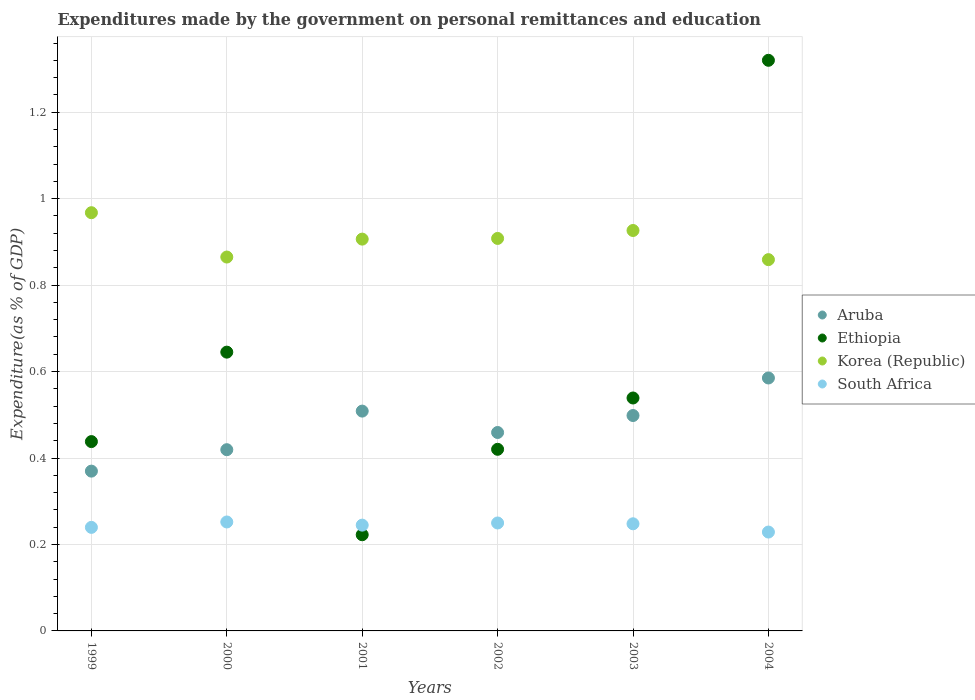Is the number of dotlines equal to the number of legend labels?
Your answer should be very brief. Yes. What is the expenditures made by the government on personal remittances and education in Aruba in 2002?
Your response must be concise. 0.46. Across all years, what is the maximum expenditures made by the government on personal remittances and education in Aruba?
Provide a short and direct response. 0.59. Across all years, what is the minimum expenditures made by the government on personal remittances and education in Korea (Republic)?
Offer a very short reply. 0.86. What is the total expenditures made by the government on personal remittances and education in Ethiopia in the graph?
Offer a very short reply. 3.58. What is the difference between the expenditures made by the government on personal remittances and education in South Africa in 2000 and that in 2004?
Provide a short and direct response. 0.02. What is the difference between the expenditures made by the government on personal remittances and education in Ethiopia in 2004 and the expenditures made by the government on personal remittances and education in Korea (Republic) in 1999?
Make the answer very short. 0.35. What is the average expenditures made by the government on personal remittances and education in South Africa per year?
Offer a very short reply. 0.24. In the year 2002, what is the difference between the expenditures made by the government on personal remittances and education in Korea (Republic) and expenditures made by the government on personal remittances and education in South Africa?
Your answer should be compact. 0.66. What is the ratio of the expenditures made by the government on personal remittances and education in South Africa in 2002 to that in 2003?
Ensure brevity in your answer.  1.01. What is the difference between the highest and the second highest expenditures made by the government on personal remittances and education in Ethiopia?
Offer a terse response. 0.68. What is the difference between the highest and the lowest expenditures made by the government on personal remittances and education in South Africa?
Keep it short and to the point. 0.02. Is it the case that in every year, the sum of the expenditures made by the government on personal remittances and education in Ethiopia and expenditures made by the government on personal remittances and education in Korea (Republic)  is greater than the sum of expenditures made by the government on personal remittances and education in Aruba and expenditures made by the government on personal remittances and education in South Africa?
Provide a succinct answer. Yes. Is it the case that in every year, the sum of the expenditures made by the government on personal remittances and education in South Africa and expenditures made by the government on personal remittances and education in Aruba  is greater than the expenditures made by the government on personal remittances and education in Ethiopia?
Your response must be concise. No. Are the values on the major ticks of Y-axis written in scientific E-notation?
Give a very brief answer. No. Where does the legend appear in the graph?
Your response must be concise. Center right. How many legend labels are there?
Your response must be concise. 4. What is the title of the graph?
Your response must be concise. Expenditures made by the government on personal remittances and education. What is the label or title of the X-axis?
Offer a terse response. Years. What is the label or title of the Y-axis?
Keep it short and to the point. Expenditure(as % of GDP). What is the Expenditure(as % of GDP) in Aruba in 1999?
Provide a succinct answer. 0.37. What is the Expenditure(as % of GDP) in Ethiopia in 1999?
Keep it short and to the point. 0.44. What is the Expenditure(as % of GDP) of Korea (Republic) in 1999?
Give a very brief answer. 0.97. What is the Expenditure(as % of GDP) of South Africa in 1999?
Your answer should be compact. 0.24. What is the Expenditure(as % of GDP) in Aruba in 2000?
Your answer should be very brief. 0.42. What is the Expenditure(as % of GDP) in Ethiopia in 2000?
Provide a short and direct response. 0.64. What is the Expenditure(as % of GDP) in Korea (Republic) in 2000?
Provide a short and direct response. 0.86. What is the Expenditure(as % of GDP) in South Africa in 2000?
Keep it short and to the point. 0.25. What is the Expenditure(as % of GDP) of Aruba in 2001?
Offer a terse response. 0.51. What is the Expenditure(as % of GDP) in Ethiopia in 2001?
Your answer should be very brief. 0.22. What is the Expenditure(as % of GDP) of Korea (Republic) in 2001?
Your answer should be very brief. 0.91. What is the Expenditure(as % of GDP) in South Africa in 2001?
Keep it short and to the point. 0.24. What is the Expenditure(as % of GDP) in Aruba in 2002?
Provide a succinct answer. 0.46. What is the Expenditure(as % of GDP) in Ethiopia in 2002?
Ensure brevity in your answer.  0.42. What is the Expenditure(as % of GDP) of Korea (Republic) in 2002?
Offer a terse response. 0.91. What is the Expenditure(as % of GDP) of South Africa in 2002?
Make the answer very short. 0.25. What is the Expenditure(as % of GDP) of Aruba in 2003?
Offer a terse response. 0.5. What is the Expenditure(as % of GDP) in Ethiopia in 2003?
Provide a succinct answer. 0.54. What is the Expenditure(as % of GDP) in Korea (Republic) in 2003?
Make the answer very short. 0.93. What is the Expenditure(as % of GDP) in South Africa in 2003?
Provide a short and direct response. 0.25. What is the Expenditure(as % of GDP) in Aruba in 2004?
Keep it short and to the point. 0.59. What is the Expenditure(as % of GDP) of Ethiopia in 2004?
Offer a very short reply. 1.32. What is the Expenditure(as % of GDP) in Korea (Republic) in 2004?
Your answer should be compact. 0.86. What is the Expenditure(as % of GDP) of South Africa in 2004?
Provide a succinct answer. 0.23. Across all years, what is the maximum Expenditure(as % of GDP) of Aruba?
Ensure brevity in your answer.  0.59. Across all years, what is the maximum Expenditure(as % of GDP) of Ethiopia?
Keep it short and to the point. 1.32. Across all years, what is the maximum Expenditure(as % of GDP) of Korea (Republic)?
Ensure brevity in your answer.  0.97. Across all years, what is the maximum Expenditure(as % of GDP) of South Africa?
Make the answer very short. 0.25. Across all years, what is the minimum Expenditure(as % of GDP) in Aruba?
Offer a terse response. 0.37. Across all years, what is the minimum Expenditure(as % of GDP) in Ethiopia?
Provide a short and direct response. 0.22. Across all years, what is the minimum Expenditure(as % of GDP) in Korea (Republic)?
Provide a short and direct response. 0.86. Across all years, what is the minimum Expenditure(as % of GDP) in South Africa?
Ensure brevity in your answer.  0.23. What is the total Expenditure(as % of GDP) of Aruba in the graph?
Provide a short and direct response. 2.84. What is the total Expenditure(as % of GDP) of Ethiopia in the graph?
Provide a succinct answer. 3.58. What is the total Expenditure(as % of GDP) of Korea (Republic) in the graph?
Offer a terse response. 5.43. What is the total Expenditure(as % of GDP) of South Africa in the graph?
Make the answer very short. 1.46. What is the difference between the Expenditure(as % of GDP) in Aruba in 1999 and that in 2000?
Ensure brevity in your answer.  -0.05. What is the difference between the Expenditure(as % of GDP) of Ethiopia in 1999 and that in 2000?
Ensure brevity in your answer.  -0.21. What is the difference between the Expenditure(as % of GDP) of Korea (Republic) in 1999 and that in 2000?
Offer a very short reply. 0.1. What is the difference between the Expenditure(as % of GDP) in South Africa in 1999 and that in 2000?
Your answer should be very brief. -0.01. What is the difference between the Expenditure(as % of GDP) of Aruba in 1999 and that in 2001?
Your answer should be compact. -0.14. What is the difference between the Expenditure(as % of GDP) in Ethiopia in 1999 and that in 2001?
Your response must be concise. 0.22. What is the difference between the Expenditure(as % of GDP) of Korea (Republic) in 1999 and that in 2001?
Ensure brevity in your answer.  0.06. What is the difference between the Expenditure(as % of GDP) of South Africa in 1999 and that in 2001?
Provide a succinct answer. -0.01. What is the difference between the Expenditure(as % of GDP) in Aruba in 1999 and that in 2002?
Provide a succinct answer. -0.09. What is the difference between the Expenditure(as % of GDP) in Ethiopia in 1999 and that in 2002?
Your answer should be compact. 0.02. What is the difference between the Expenditure(as % of GDP) of Korea (Republic) in 1999 and that in 2002?
Make the answer very short. 0.06. What is the difference between the Expenditure(as % of GDP) in South Africa in 1999 and that in 2002?
Provide a short and direct response. -0.01. What is the difference between the Expenditure(as % of GDP) of Aruba in 1999 and that in 2003?
Ensure brevity in your answer.  -0.13. What is the difference between the Expenditure(as % of GDP) of Ethiopia in 1999 and that in 2003?
Offer a very short reply. -0.1. What is the difference between the Expenditure(as % of GDP) of Korea (Republic) in 1999 and that in 2003?
Provide a succinct answer. 0.04. What is the difference between the Expenditure(as % of GDP) of South Africa in 1999 and that in 2003?
Ensure brevity in your answer.  -0.01. What is the difference between the Expenditure(as % of GDP) in Aruba in 1999 and that in 2004?
Provide a short and direct response. -0.22. What is the difference between the Expenditure(as % of GDP) in Ethiopia in 1999 and that in 2004?
Your answer should be compact. -0.88. What is the difference between the Expenditure(as % of GDP) in Korea (Republic) in 1999 and that in 2004?
Offer a very short reply. 0.11. What is the difference between the Expenditure(as % of GDP) of South Africa in 1999 and that in 2004?
Provide a short and direct response. 0.01. What is the difference between the Expenditure(as % of GDP) in Aruba in 2000 and that in 2001?
Provide a short and direct response. -0.09. What is the difference between the Expenditure(as % of GDP) of Ethiopia in 2000 and that in 2001?
Provide a short and direct response. 0.42. What is the difference between the Expenditure(as % of GDP) of Korea (Republic) in 2000 and that in 2001?
Offer a terse response. -0.04. What is the difference between the Expenditure(as % of GDP) of South Africa in 2000 and that in 2001?
Provide a short and direct response. 0.01. What is the difference between the Expenditure(as % of GDP) of Aruba in 2000 and that in 2002?
Your answer should be very brief. -0.04. What is the difference between the Expenditure(as % of GDP) of Ethiopia in 2000 and that in 2002?
Keep it short and to the point. 0.22. What is the difference between the Expenditure(as % of GDP) of Korea (Republic) in 2000 and that in 2002?
Ensure brevity in your answer.  -0.04. What is the difference between the Expenditure(as % of GDP) of South Africa in 2000 and that in 2002?
Give a very brief answer. 0. What is the difference between the Expenditure(as % of GDP) in Aruba in 2000 and that in 2003?
Your answer should be very brief. -0.08. What is the difference between the Expenditure(as % of GDP) of Ethiopia in 2000 and that in 2003?
Your answer should be compact. 0.11. What is the difference between the Expenditure(as % of GDP) of Korea (Republic) in 2000 and that in 2003?
Make the answer very short. -0.06. What is the difference between the Expenditure(as % of GDP) of South Africa in 2000 and that in 2003?
Ensure brevity in your answer.  0. What is the difference between the Expenditure(as % of GDP) in Aruba in 2000 and that in 2004?
Make the answer very short. -0.17. What is the difference between the Expenditure(as % of GDP) of Ethiopia in 2000 and that in 2004?
Provide a succinct answer. -0.68. What is the difference between the Expenditure(as % of GDP) of Korea (Republic) in 2000 and that in 2004?
Your answer should be very brief. 0.01. What is the difference between the Expenditure(as % of GDP) in South Africa in 2000 and that in 2004?
Make the answer very short. 0.02. What is the difference between the Expenditure(as % of GDP) in Aruba in 2001 and that in 2002?
Offer a very short reply. 0.05. What is the difference between the Expenditure(as % of GDP) in Ethiopia in 2001 and that in 2002?
Give a very brief answer. -0.2. What is the difference between the Expenditure(as % of GDP) in Korea (Republic) in 2001 and that in 2002?
Offer a very short reply. -0. What is the difference between the Expenditure(as % of GDP) of South Africa in 2001 and that in 2002?
Your response must be concise. -0.01. What is the difference between the Expenditure(as % of GDP) of Aruba in 2001 and that in 2003?
Provide a short and direct response. 0.01. What is the difference between the Expenditure(as % of GDP) of Ethiopia in 2001 and that in 2003?
Provide a succinct answer. -0.32. What is the difference between the Expenditure(as % of GDP) of Korea (Republic) in 2001 and that in 2003?
Provide a short and direct response. -0.02. What is the difference between the Expenditure(as % of GDP) in South Africa in 2001 and that in 2003?
Provide a succinct answer. -0. What is the difference between the Expenditure(as % of GDP) in Aruba in 2001 and that in 2004?
Offer a very short reply. -0.08. What is the difference between the Expenditure(as % of GDP) of Ethiopia in 2001 and that in 2004?
Offer a very short reply. -1.1. What is the difference between the Expenditure(as % of GDP) of Korea (Republic) in 2001 and that in 2004?
Your response must be concise. 0.05. What is the difference between the Expenditure(as % of GDP) of South Africa in 2001 and that in 2004?
Ensure brevity in your answer.  0.02. What is the difference between the Expenditure(as % of GDP) in Aruba in 2002 and that in 2003?
Ensure brevity in your answer.  -0.04. What is the difference between the Expenditure(as % of GDP) in Ethiopia in 2002 and that in 2003?
Give a very brief answer. -0.12. What is the difference between the Expenditure(as % of GDP) in Korea (Republic) in 2002 and that in 2003?
Your answer should be compact. -0.02. What is the difference between the Expenditure(as % of GDP) of South Africa in 2002 and that in 2003?
Provide a succinct answer. 0. What is the difference between the Expenditure(as % of GDP) in Aruba in 2002 and that in 2004?
Your answer should be compact. -0.13. What is the difference between the Expenditure(as % of GDP) of Ethiopia in 2002 and that in 2004?
Provide a succinct answer. -0.9. What is the difference between the Expenditure(as % of GDP) in Korea (Republic) in 2002 and that in 2004?
Your answer should be compact. 0.05. What is the difference between the Expenditure(as % of GDP) in South Africa in 2002 and that in 2004?
Provide a short and direct response. 0.02. What is the difference between the Expenditure(as % of GDP) of Aruba in 2003 and that in 2004?
Ensure brevity in your answer.  -0.09. What is the difference between the Expenditure(as % of GDP) of Ethiopia in 2003 and that in 2004?
Provide a short and direct response. -0.78. What is the difference between the Expenditure(as % of GDP) in Korea (Republic) in 2003 and that in 2004?
Make the answer very short. 0.07. What is the difference between the Expenditure(as % of GDP) of South Africa in 2003 and that in 2004?
Offer a very short reply. 0.02. What is the difference between the Expenditure(as % of GDP) of Aruba in 1999 and the Expenditure(as % of GDP) of Ethiopia in 2000?
Make the answer very short. -0.28. What is the difference between the Expenditure(as % of GDP) of Aruba in 1999 and the Expenditure(as % of GDP) of Korea (Republic) in 2000?
Offer a terse response. -0.5. What is the difference between the Expenditure(as % of GDP) of Aruba in 1999 and the Expenditure(as % of GDP) of South Africa in 2000?
Your response must be concise. 0.12. What is the difference between the Expenditure(as % of GDP) in Ethiopia in 1999 and the Expenditure(as % of GDP) in Korea (Republic) in 2000?
Keep it short and to the point. -0.43. What is the difference between the Expenditure(as % of GDP) of Ethiopia in 1999 and the Expenditure(as % of GDP) of South Africa in 2000?
Provide a short and direct response. 0.19. What is the difference between the Expenditure(as % of GDP) in Korea (Republic) in 1999 and the Expenditure(as % of GDP) in South Africa in 2000?
Your response must be concise. 0.72. What is the difference between the Expenditure(as % of GDP) in Aruba in 1999 and the Expenditure(as % of GDP) in Ethiopia in 2001?
Your answer should be compact. 0.15. What is the difference between the Expenditure(as % of GDP) in Aruba in 1999 and the Expenditure(as % of GDP) in Korea (Republic) in 2001?
Offer a very short reply. -0.54. What is the difference between the Expenditure(as % of GDP) of Aruba in 1999 and the Expenditure(as % of GDP) of South Africa in 2001?
Provide a short and direct response. 0.12. What is the difference between the Expenditure(as % of GDP) of Ethiopia in 1999 and the Expenditure(as % of GDP) of Korea (Republic) in 2001?
Your response must be concise. -0.47. What is the difference between the Expenditure(as % of GDP) in Ethiopia in 1999 and the Expenditure(as % of GDP) in South Africa in 2001?
Offer a very short reply. 0.19. What is the difference between the Expenditure(as % of GDP) in Korea (Republic) in 1999 and the Expenditure(as % of GDP) in South Africa in 2001?
Offer a very short reply. 0.72. What is the difference between the Expenditure(as % of GDP) in Aruba in 1999 and the Expenditure(as % of GDP) in Ethiopia in 2002?
Give a very brief answer. -0.05. What is the difference between the Expenditure(as % of GDP) of Aruba in 1999 and the Expenditure(as % of GDP) of Korea (Republic) in 2002?
Provide a succinct answer. -0.54. What is the difference between the Expenditure(as % of GDP) in Aruba in 1999 and the Expenditure(as % of GDP) in South Africa in 2002?
Your answer should be very brief. 0.12. What is the difference between the Expenditure(as % of GDP) in Ethiopia in 1999 and the Expenditure(as % of GDP) in Korea (Republic) in 2002?
Your answer should be very brief. -0.47. What is the difference between the Expenditure(as % of GDP) of Ethiopia in 1999 and the Expenditure(as % of GDP) of South Africa in 2002?
Ensure brevity in your answer.  0.19. What is the difference between the Expenditure(as % of GDP) in Korea (Republic) in 1999 and the Expenditure(as % of GDP) in South Africa in 2002?
Keep it short and to the point. 0.72. What is the difference between the Expenditure(as % of GDP) in Aruba in 1999 and the Expenditure(as % of GDP) in Ethiopia in 2003?
Make the answer very short. -0.17. What is the difference between the Expenditure(as % of GDP) in Aruba in 1999 and the Expenditure(as % of GDP) in Korea (Republic) in 2003?
Your answer should be compact. -0.56. What is the difference between the Expenditure(as % of GDP) in Aruba in 1999 and the Expenditure(as % of GDP) in South Africa in 2003?
Your response must be concise. 0.12. What is the difference between the Expenditure(as % of GDP) of Ethiopia in 1999 and the Expenditure(as % of GDP) of Korea (Republic) in 2003?
Offer a very short reply. -0.49. What is the difference between the Expenditure(as % of GDP) of Ethiopia in 1999 and the Expenditure(as % of GDP) of South Africa in 2003?
Your answer should be compact. 0.19. What is the difference between the Expenditure(as % of GDP) in Korea (Republic) in 1999 and the Expenditure(as % of GDP) in South Africa in 2003?
Your answer should be compact. 0.72. What is the difference between the Expenditure(as % of GDP) in Aruba in 1999 and the Expenditure(as % of GDP) in Ethiopia in 2004?
Ensure brevity in your answer.  -0.95. What is the difference between the Expenditure(as % of GDP) of Aruba in 1999 and the Expenditure(as % of GDP) of Korea (Republic) in 2004?
Offer a very short reply. -0.49. What is the difference between the Expenditure(as % of GDP) in Aruba in 1999 and the Expenditure(as % of GDP) in South Africa in 2004?
Keep it short and to the point. 0.14. What is the difference between the Expenditure(as % of GDP) in Ethiopia in 1999 and the Expenditure(as % of GDP) in Korea (Republic) in 2004?
Ensure brevity in your answer.  -0.42. What is the difference between the Expenditure(as % of GDP) of Ethiopia in 1999 and the Expenditure(as % of GDP) of South Africa in 2004?
Make the answer very short. 0.21. What is the difference between the Expenditure(as % of GDP) in Korea (Republic) in 1999 and the Expenditure(as % of GDP) in South Africa in 2004?
Make the answer very short. 0.74. What is the difference between the Expenditure(as % of GDP) of Aruba in 2000 and the Expenditure(as % of GDP) of Ethiopia in 2001?
Provide a succinct answer. 0.2. What is the difference between the Expenditure(as % of GDP) in Aruba in 2000 and the Expenditure(as % of GDP) in Korea (Republic) in 2001?
Give a very brief answer. -0.49. What is the difference between the Expenditure(as % of GDP) of Aruba in 2000 and the Expenditure(as % of GDP) of South Africa in 2001?
Offer a very short reply. 0.17. What is the difference between the Expenditure(as % of GDP) in Ethiopia in 2000 and the Expenditure(as % of GDP) in Korea (Republic) in 2001?
Your answer should be compact. -0.26. What is the difference between the Expenditure(as % of GDP) of Ethiopia in 2000 and the Expenditure(as % of GDP) of South Africa in 2001?
Ensure brevity in your answer.  0.4. What is the difference between the Expenditure(as % of GDP) of Korea (Republic) in 2000 and the Expenditure(as % of GDP) of South Africa in 2001?
Provide a succinct answer. 0.62. What is the difference between the Expenditure(as % of GDP) of Aruba in 2000 and the Expenditure(as % of GDP) of Ethiopia in 2002?
Make the answer very short. -0. What is the difference between the Expenditure(as % of GDP) in Aruba in 2000 and the Expenditure(as % of GDP) in Korea (Republic) in 2002?
Your answer should be compact. -0.49. What is the difference between the Expenditure(as % of GDP) of Aruba in 2000 and the Expenditure(as % of GDP) of South Africa in 2002?
Make the answer very short. 0.17. What is the difference between the Expenditure(as % of GDP) in Ethiopia in 2000 and the Expenditure(as % of GDP) in Korea (Republic) in 2002?
Your answer should be compact. -0.26. What is the difference between the Expenditure(as % of GDP) in Ethiopia in 2000 and the Expenditure(as % of GDP) in South Africa in 2002?
Keep it short and to the point. 0.4. What is the difference between the Expenditure(as % of GDP) in Korea (Republic) in 2000 and the Expenditure(as % of GDP) in South Africa in 2002?
Your answer should be compact. 0.62. What is the difference between the Expenditure(as % of GDP) of Aruba in 2000 and the Expenditure(as % of GDP) of Ethiopia in 2003?
Offer a terse response. -0.12. What is the difference between the Expenditure(as % of GDP) of Aruba in 2000 and the Expenditure(as % of GDP) of Korea (Republic) in 2003?
Offer a very short reply. -0.51. What is the difference between the Expenditure(as % of GDP) in Aruba in 2000 and the Expenditure(as % of GDP) in South Africa in 2003?
Give a very brief answer. 0.17. What is the difference between the Expenditure(as % of GDP) in Ethiopia in 2000 and the Expenditure(as % of GDP) in Korea (Republic) in 2003?
Keep it short and to the point. -0.28. What is the difference between the Expenditure(as % of GDP) of Ethiopia in 2000 and the Expenditure(as % of GDP) of South Africa in 2003?
Offer a terse response. 0.4. What is the difference between the Expenditure(as % of GDP) of Korea (Republic) in 2000 and the Expenditure(as % of GDP) of South Africa in 2003?
Provide a succinct answer. 0.62. What is the difference between the Expenditure(as % of GDP) in Aruba in 2000 and the Expenditure(as % of GDP) in Ethiopia in 2004?
Offer a terse response. -0.9. What is the difference between the Expenditure(as % of GDP) in Aruba in 2000 and the Expenditure(as % of GDP) in Korea (Republic) in 2004?
Offer a terse response. -0.44. What is the difference between the Expenditure(as % of GDP) of Aruba in 2000 and the Expenditure(as % of GDP) of South Africa in 2004?
Your answer should be compact. 0.19. What is the difference between the Expenditure(as % of GDP) of Ethiopia in 2000 and the Expenditure(as % of GDP) of Korea (Republic) in 2004?
Provide a short and direct response. -0.21. What is the difference between the Expenditure(as % of GDP) in Ethiopia in 2000 and the Expenditure(as % of GDP) in South Africa in 2004?
Keep it short and to the point. 0.42. What is the difference between the Expenditure(as % of GDP) in Korea (Republic) in 2000 and the Expenditure(as % of GDP) in South Africa in 2004?
Provide a short and direct response. 0.64. What is the difference between the Expenditure(as % of GDP) in Aruba in 2001 and the Expenditure(as % of GDP) in Ethiopia in 2002?
Provide a succinct answer. 0.09. What is the difference between the Expenditure(as % of GDP) in Aruba in 2001 and the Expenditure(as % of GDP) in Korea (Republic) in 2002?
Provide a succinct answer. -0.4. What is the difference between the Expenditure(as % of GDP) in Aruba in 2001 and the Expenditure(as % of GDP) in South Africa in 2002?
Give a very brief answer. 0.26. What is the difference between the Expenditure(as % of GDP) of Ethiopia in 2001 and the Expenditure(as % of GDP) of Korea (Republic) in 2002?
Your answer should be very brief. -0.69. What is the difference between the Expenditure(as % of GDP) of Ethiopia in 2001 and the Expenditure(as % of GDP) of South Africa in 2002?
Offer a very short reply. -0.03. What is the difference between the Expenditure(as % of GDP) of Korea (Republic) in 2001 and the Expenditure(as % of GDP) of South Africa in 2002?
Ensure brevity in your answer.  0.66. What is the difference between the Expenditure(as % of GDP) of Aruba in 2001 and the Expenditure(as % of GDP) of Ethiopia in 2003?
Provide a succinct answer. -0.03. What is the difference between the Expenditure(as % of GDP) in Aruba in 2001 and the Expenditure(as % of GDP) in Korea (Republic) in 2003?
Ensure brevity in your answer.  -0.42. What is the difference between the Expenditure(as % of GDP) in Aruba in 2001 and the Expenditure(as % of GDP) in South Africa in 2003?
Your answer should be very brief. 0.26. What is the difference between the Expenditure(as % of GDP) of Ethiopia in 2001 and the Expenditure(as % of GDP) of Korea (Republic) in 2003?
Keep it short and to the point. -0.7. What is the difference between the Expenditure(as % of GDP) in Ethiopia in 2001 and the Expenditure(as % of GDP) in South Africa in 2003?
Make the answer very short. -0.03. What is the difference between the Expenditure(as % of GDP) of Korea (Republic) in 2001 and the Expenditure(as % of GDP) of South Africa in 2003?
Ensure brevity in your answer.  0.66. What is the difference between the Expenditure(as % of GDP) of Aruba in 2001 and the Expenditure(as % of GDP) of Ethiopia in 2004?
Give a very brief answer. -0.81. What is the difference between the Expenditure(as % of GDP) of Aruba in 2001 and the Expenditure(as % of GDP) of Korea (Republic) in 2004?
Make the answer very short. -0.35. What is the difference between the Expenditure(as % of GDP) in Aruba in 2001 and the Expenditure(as % of GDP) in South Africa in 2004?
Offer a very short reply. 0.28. What is the difference between the Expenditure(as % of GDP) in Ethiopia in 2001 and the Expenditure(as % of GDP) in Korea (Republic) in 2004?
Offer a terse response. -0.64. What is the difference between the Expenditure(as % of GDP) of Ethiopia in 2001 and the Expenditure(as % of GDP) of South Africa in 2004?
Your answer should be very brief. -0.01. What is the difference between the Expenditure(as % of GDP) of Korea (Republic) in 2001 and the Expenditure(as % of GDP) of South Africa in 2004?
Offer a terse response. 0.68. What is the difference between the Expenditure(as % of GDP) of Aruba in 2002 and the Expenditure(as % of GDP) of Ethiopia in 2003?
Provide a succinct answer. -0.08. What is the difference between the Expenditure(as % of GDP) of Aruba in 2002 and the Expenditure(as % of GDP) of Korea (Republic) in 2003?
Ensure brevity in your answer.  -0.47. What is the difference between the Expenditure(as % of GDP) of Aruba in 2002 and the Expenditure(as % of GDP) of South Africa in 2003?
Offer a terse response. 0.21. What is the difference between the Expenditure(as % of GDP) in Ethiopia in 2002 and the Expenditure(as % of GDP) in Korea (Republic) in 2003?
Your answer should be very brief. -0.51. What is the difference between the Expenditure(as % of GDP) of Ethiopia in 2002 and the Expenditure(as % of GDP) of South Africa in 2003?
Offer a terse response. 0.17. What is the difference between the Expenditure(as % of GDP) of Korea (Republic) in 2002 and the Expenditure(as % of GDP) of South Africa in 2003?
Ensure brevity in your answer.  0.66. What is the difference between the Expenditure(as % of GDP) in Aruba in 2002 and the Expenditure(as % of GDP) in Ethiopia in 2004?
Offer a very short reply. -0.86. What is the difference between the Expenditure(as % of GDP) in Aruba in 2002 and the Expenditure(as % of GDP) in Korea (Republic) in 2004?
Provide a succinct answer. -0.4. What is the difference between the Expenditure(as % of GDP) of Aruba in 2002 and the Expenditure(as % of GDP) of South Africa in 2004?
Offer a very short reply. 0.23. What is the difference between the Expenditure(as % of GDP) of Ethiopia in 2002 and the Expenditure(as % of GDP) of Korea (Republic) in 2004?
Provide a succinct answer. -0.44. What is the difference between the Expenditure(as % of GDP) in Ethiopia in 2002 and the Expenditure(as % of GDP) in South Africa in 2004?
Give a very brief answer. 0.19. What is the difference between the Expenditure(as % of GDP) of Korea (Republic) in 2002 and the Expenditure(as % of GDP) of South Africa in 2004?
Your answer should be very brief. 0.68. What is the difference between the Expenditure(as % of GDP) in Aruba in 2003 and the Expenditure(as % of GDP) in Ethiopia in 2004?
Provide a succinct answer. -0.82. What is the difference between the Expenditure(as % of GDP) of Aruba in 2003 and the Expenditure(as % of GDP) of Korea (Republic) in 2004?
Provide a short and direct response. -0.36. What is the difference between the Expenditure(as % of GDP) in Aruba in 2003 and the Expenditure(as % of GDP) in South Africa in 2004?
Keep it short and to the point. 0.27. What is the difference between the Expenditure(as % of GDP) of Ethiopia in 2003 and the Expenditure(as % of GDP) of Korea (Republic) in 2004?
Offer a terse response. -0.32. What is the difference between the Expenditure(as % of GDP) of Ethiopia in 2003 and the Expenditure(as % of GDP) of South Africa in 2004?
Your answer should be compact. 0.31. What is the difference between the Expenditure(as % of GDP) in Korea (Republic) in 2003 and the Expenditure(as % of GDP) in South Africa in 2004?
Provide a succinct answer. 0.7. What is the average Expenditure(as % of GDP) in Aruba per year?
Offer a terse response. 0.47. What is the average Expenditure(as % of GDP) in Ethiopia per year?
Your response must be concise. 0.6. What is the average Expenditure(as % of GDP) in Korea (Republic) per year?
Ensure brevity in your answer.  0.91. What is the average Expenditure(as % of GDP) of South Africa per year?
Provide a succinct answer. 0.24. In the year 1999, what is the difference between the Expenditure(as % of GDP) of Aruba and Expenditure(as % of GDP) of Ethiopia?
Give a very brief answer. -0.07. In the year 1999, what is the difference between the Expenditure(as % of GDP) of Aruba and Expenditure(as % of GDP) of Korea (Republic)?
Ensure brevity in your answer.  -0.6. In the year 1999, what is the difference between the Expenditure(as % of GDP) in Aruba and Expenditure(as % of GDP) in South Africa?
Keep it short and to the point. 0.13. In the year 1999, what is the difference between the Expenditure(as % of GDP) of Ethiopia and Expenditure(as % of GDP) of Korea (Republic)?
Provide a short and direct response. -0.53. In the year 1999, what is the difference between the Expenditure(as % of GDP) in Ethiopia and Expenditure(as % of GDP) in South Africa?
Your answer should be very brief. 0.2. In the year 1999, what is the difference between the Expenditure(as % of GDP) of Korea (Republic) and Expenditure(as % of GDP) of South Africa?
Make the answer very short. 0.73. In the year 2000, what is the difference between the Expenditure(as % of GDP) of Aruba and Expenditure(as % of GDP) of Ethiopia?
Give a very brief answer. -0.23. In the year 2000, what is the difference between the Expenditure(as % of GDP) of Aruba and Expenditure(as % of GDP) of Korea (Republic)?
Your answer should be very brief. -0.45. In the year 2000, what is the difference between the Expenditure(as % of GDP) in Aruba and Expenditure(as % of GDP) in South Africa?
Your response must be concise. 0.17. In the year 2000, what is the difference between the Expenditure(as % of GDP) of Ethiopia and Expenditure(as % of GDP) of Korea (Republic)?
Ensure brevity in your answer.  -0.22. In the year 2000, what is the difference between the Expenditure(as % of GDP) in Ethiopia and Expenditure(as % of GDP) in South Africa?
Your response must be concise. 0.39. In the year 2000, what is the difference between the Expenditure(as % of GDP) in Korea (Republic) and Expenditure(as % of GDP) in South Africa?
Your answer should be compact. 0.61. In the year 2001, what is the difference between the Expenditure(as % of GDP) of Aruba and Expenditure(as % of GDP) of Ethiopia?
Give a very brief answer. 0.29. In the year 2001, what is the difference between the Expenditure(as % of GDP) in Aruba and Expenditure(as % of GDP) in Korea (Republic)?
Keep it short and to the point. -0.4. In the year 2001, what is the difference between the Expenditure(as % of GDP) of Aruba and Expenditure(as % of GDP) of South Africa?
Offer a terse response. 0.26. In the year 2001, what is the difference between the Expenditure(as % of GDP) of Ethiopia and Expenditure(as % of GDP) of Korea (Republic)?
Ensure brevity in your answer.  -0.68. In the year 2001, what is the difference between the Expenditure(as % of GDP) of Ethiopia and Expenditure(as % of GDP) of South Africa?
Provide a short and direct response. -0.02. In the year 2001, what is the difference between the Expenditure(as % of GDP) in Korea (Republic) and Expenditure(as % of GDP) in South Africa?
Your answer should be compact. 0.66. In the year 2002, what is the difference between the Expenditure(as % of GDP) in Aruba and Expenditure(as % of GDP) in Ethiopia?
Your answer should be compact. 0.04. In the year 2002, what is the difference between the Expenditure(as % of GDP) in Aruba and Expenditure(as % of GDP) in Korea (Republic)?
Keep it short and to the point. -0.45. In the year 2002, what is the difference between the Expenditure(as % of GDP) of Aruba and Expenditure(as % of GDP) of South Africa?
Your answer should be very brief. 0.21. In the year 2002, what is the difference between the Expenditure(as % of GDP) in Ethiopia and Expenditure(as % of GDP) in Korea (Republic)?
Keep it short and to the point. -0.49. In the year 2002, what is the difference between the Expenditure(as % of GDP) of Ethiopia and Expenditure(as % of GDP) of South Africa?
Make the answer very short. 0.17. In the year 2002, what is the difference between the Expenditure(as % of GDP) of Korea (Republic) and Expenditure(as % of GDP) of South Africa?
Your response must be concise. 0.66. In the year 2003, what is the difference between the Expenditure(as % of GDP) in Aruba and Expenditure(as % of GDP) in Ethiopia?
Offer a very short reply. -0.04. In the year 2003, what is the difference between the Expenditure(as % of GDP) in Aruba and Expenditure(as % of GDP) in Korea (Republic)?
Make the answer very short. -0.43. In the year 2003, what is the difference between the Expenditure(as % of GDP) of Aruba and Expenditure(as % of GDP) of South Africa?
Offer a very short reply. 0.25. In the year 2003, what is the difference between the Expenditure(as % of GDP) in Ethiopia and Expenditure(as % of GDP) in Korea (Republic)?
Your response must be concise. -0.39. In the year 2003, what is the difference between the Expenditure(as % of GDP) in Ethiopia and Expenditure(as % of GDP) in South Africa?
Offer a very short reply. 0.29. In the year 2003, what is the difference between the Expenditure(as % of GDP) in Korea (Republic) and Expenditure(as % of GDP) in South Africa?
Your response must be concise. 0.68. In the year 2004, what is the difference between the Expenditure(as % of GDP) of Aruba and Expenditure(as % of GDP) of Ethiopia?
Provide a succinct answer. -0.73. In the year 2004, what is the difference between the Expenditure(as % of GDP) of Aruba and Expenditure(as % of GDP) of Korea (Republic)?
Ensure brevity in your answer.  -0.27. In the year 2004, what is the difference between the Expenditure(as % of GDP) of Aruba and Expenditure(as % of GDP) of South Africa?
Provide a succinct answer. 0.36. In the year 2004, what is the difference between the Expenditure(as % of GDP) in Ethiopia and Expenditure(as % of GDP) in Korea (Republic)?
Your response must be concise. 0.46. In the year 2004, what is the difference between the Expenditure(as % of GDP) of Ethiopia and Expenditure(as % of GDP) of South Africa?
Give a very brief answer. 1.09. In the year 2004, what is the difference between the Expenditure(as % of GDP) of Korea (Republic) and Expenditure(as % of GDP) of South Africa?
Make the answer very short. 0.63. What is the ratio of the Expenditure(as % of GDP) of Aruba in 1999 to that in 2000?
Your response must be concise. 0.88. What is the ratio of the Expenditure(as % of GDP) of Ethiopia in 1999 to that in 2000?
Make the answer very short. 0.68. What is the ratio of the Expenditure(as % of GDP) of Korea (Republic) in 1999 to that in 2000?
Your response must be concise. 1.12. What is the ratio of the Expenditure(as % of GDP) of South Africa in 1999 to that in 2000?
Offer a very short reply. 0.95. What is the ratio of the Expenditure(as % of GDP) of Aruba in 1999 to that in 2001?
Give a very brief answer. 0.73. What is the ratio of the Expenditure(as % of GDP) of Ethiopia in 1999 to that in 2001?
Offer a terse response. 1.97. What is the ratio of the Expenditure(as % of GDP) in Korea (Republic) in 1999 to that in 2001?
Provide a succinct answer. 1.07. What is the ratio of the Expenditure(as % of GDP) of South Africa in 1999 to that in 2001?
Offer a terse response. 0.98. What is the ratio of the Expenditure(as % of GDP) in Aruba in 1999 to that in 2002?
Make the answer very short. 0.81. What is the ratio of the Expenditure(as % of GDP) in Ethiopia in 1999 to that in 2002?
Make the answer very short. 1.04. What is the ratio of the Expenditure(as % of GDP) in Korea (Republic) in 1999 to that in 2002?
Your answer should be very brief. 1.07. What is the ratio of the Expenditure(as % of GDP) of South Africa in 1999 to that in 2002?
Make the answer very short. 0.96. What is the ratio of the Expenditure(as % of GDP) of Aruba in 1999 to that in 2003?
Provide a succinct answer. 0.74. What is the ratio of the Expenditure(as % of GDP) of Ethiopia in 1999 to that in 2003?
Ensure brevity in your answer.  0.81. What is the ratio of the Expenditure(as % of GDP) of Korea (Republic) in 1999 to that in 2003?
Provide a short and direct response. 1.04. What is the ratio of the Expenditure(as % of GDP) in South Africa in 1999 to that in 2003?
Offer a terse response. 0.97. What is the ratio of the Expenditure(as % of GDP) of Aruba in 1999 to that in 2004?
Offer a very short reply. 0.63. What is the ratio of the Expenditure(as % of GDP) of Ethiopia in 1999 to that in 2004?
Your answer should be compact. 0.33. What is the ratio of the Expenditure(as % of GDP) in Korea (Republic) in 1999 to that in 2004?
Offer a terse response. 1.13. What is the ratio of the Expenditure(as % of GDP) in South Africa in 1999 to that in 2004?
Provide a short and direct response. 1.05. What is the ratio of the Expenditure(as % of GDP) of Aruba in 2000 to that in 2001?
Provide a succinct answer. 0.82. What is the ratio of the Expenditure(as % of GDP) of Ethiopia in 2000 to that in 2001?
Keep it short and to the point. 2.9. What is the ratio of the Expenditure(as % of GDP) of Korea (Republic) in 2000 to that in 2001?
Ensure brevity in your answer.  0.95. What is the ratio of the Expenditure(as % of GDP) of South Africa in 2000 to that in 2001?
Your answer should be very brief. 1.03. What is the ratio of the Expenditure(as % of GDP) in Aruba in 2000 to that in 2002?
Keep it short and to the point. 0.91. What is the ratio of the Expenditure(as % of GDP) in Ethiopia in 2000 to that in 2002?
Your answer should be compact. 1.53. What is the ratio of the Expenditure(as % of GDP) of Korea (Republic) in 2000 to that in 2002?
Keep it short and to the point. 0.95. What is the ratio of the Expenditure(as % of GDP) of South Africa in 2000 to that in 2002?
Your response must be concise. 1.01. What is the ratio of the Expenditure(as % of GDP) of Aruba in 2000 to that in 2003?
Keep it short and to the point. 0.84. What is the ratio of the Expenditure(as % of GDP) of Ethiopia in 2000 to that in 2003?
Your answer should be very brief. 1.2. What is the ratio of the Expenditure(as % of GDP) in Korea (Republic) in 2000 to that in 2003?
Provide a short and direct response. 0.93. What is the ratio of the Expenditure(as % of GDP) in South Africa in 2000 to that in 2003?
Ensure brevity in your answer.  1.02. What is the ratio of the Expenditure(as % of GDP) in Aruba in 2000 to that in 2004?
Offer a very short reply. 0.72. What is the ratio of the Expenditure(as % of GDP) of Ethiopia in 2000 to that in 2004?
Your answer should be compact. 0.49. What is the ratio of the Expenditure(as % of GDP) in Korea (Republic) in 2000 to that in 2004?
Offer a very short reply. 1.01. What is the ratio of the Expenditure(as % of GDP) of South Africa in 2000 to that in 2004?
Your response must be concise. 1.1. What is the ratio of the Expenditure(as % of GDP) of Aruba in 2001 to that in 2002?
Keep it short and to the point. 1.11. What is the ratio of the Expenditure(as % of GDP) in Ethiopia in 2001 to that in 2002?
Provide a succinct answer. 0.53. What is the ratio of the Expenditure(as % of GDP) in Aruba in 2001 to that in 2003?
Provide a succinct answer. 1.02. What is the ratio of the Expenditure(as % of GDP) of Ethiopia in 2001 to that in 2003?
Offer a terse response. 0.41. What is the ratio of the Expenditure(as % of GDP) in Korea (Republic) in 2001 to that in 2003?
Your answer should be very brief. 0.98. What is the ratio of the Expenditure(as % of GDP) in South Africa in 2001 to that in 2003?
Provide a succinct answer. 0.99. What is the ratio of the Expenditure(as % of GDP) of Aruba in 2001 to that in 2004?
Offer a very short reply. 0.87. What is the ratio of the Expenditure(as % of GDP) of Ethiopia in 2001 to that in 2004?
Ensure brevity in your answer.  0.17. What is the ratio of the Expenditure(as % of GDP) in Korea (Republic) in 2001 to that in 2004?
Your response must be concise. 1.06. What is the ratio of the Expenditure(as % of GDP) of South Africa in 2001 to that in 2004?
Offer a terse response. 1.07. What is the ratio of the Expenditure(as % of GDP) in Aruba in 2002 to that in 2003?
Offer a terse response. 0.92. What is the ratio of the Expenditure(as % of GDP) of Ethiopia in 2002 to that in 2003?
Provide a short and direct response. 0.78. What is the ratio of the Expenditure(as % of GDP) of Korea (Republic) in 2002 to that in 2003?
Provide a succinct answer. 0.98. What is the ratio of the Expenditure(as % of GDP) in South Africa in 2002 to that in 2003?
Provide a succinct answer. 1.01. What is the ratio of the Expenditure(as % of GDP) of Aruba in 2002 to that in 2004?
Provide a short and direct response. 0.78. What is the ratio of the Expenditure(as % of GDP) in Ethiopia in 2002 to that in 2004?
Ensure brevity in your answer.  0.32. What is the ratio of the Expenditure(as % of GDP) in Korea (Republic) in 2002 to that in 2004?
Make the answer very short. 1.06. What is the ratio of the Expenditure(as % of GDP) of South Africa in 2002 to that in 2004?
Your response must be concise. 1.09. What is the ratio of the Expenditure(as % of GDP) in Aruba in 2003 to that in 2004?
Your answer should be compact. 0.85. What is the ratio of the Expenditure(as % of GDP) in Ethiopia in 2003 to that in 2004?
Provide a short and direct response. 0.41. What is the ratio of the Expenditure(as % of GDP) in Korea (Republic) in 2003 to that in 2004?
Give a very brief answer. 1.08. What is the ratio of the Expenditure(as % of GDP) in South Africa in 2003 to that in 2004?
Your answer should be compact. 1.08. What is the difference between the highest and the second highest Expenditure(as % of GDP) of Aruba?
Your response must be concise. 0.08. What is the difference between the highest and the second highest Expenditure(as % of GDP) in Ethiopia?
Keep it short and to the point. 0.68. What is the difference between the highest and the second highest Expenditure(as % of GDP) in Korea (Republic)?
Give a very brief answer. 0.04. What is the difference between the highest and the second highest Expenditure(as % of GDP) in South Africa?
Keep it short and to the point. 0. What is the difference between the highest and the lowest Expenditure(as % of GDP) in Aruba?
Offer a very short reply. 0.22. What is the difference between the highest and the lowest Expenditure(as % of GDP) in Ethiopia?
Your answer should be compact. 1.1. What is the difference between the highest and the lowest Expenditure(as % of GDP) in Korea (Republic)?
Offer a very short reply. 0.11. What is the difference between the highest and the lowest Expenditure(as % of GDP) in South Africa?
Keep it short and to the point. 0.02. 